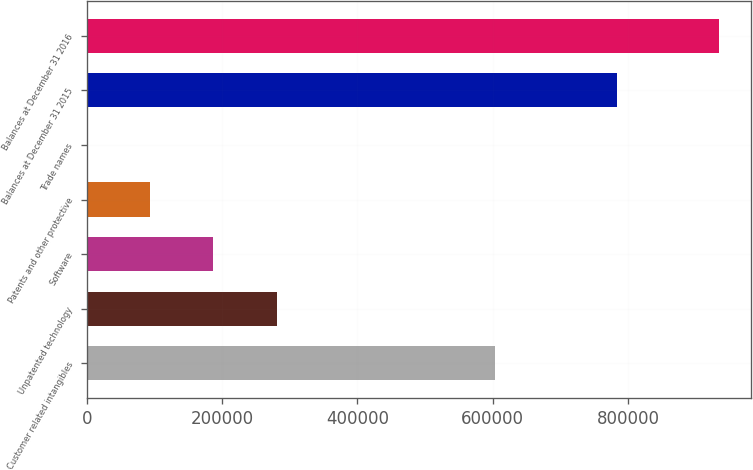Convert chart. <chart><loc_0><loc_0><loc_500><loc_500><bar_chart><fcel>Customer related intangibles<fcel>Unpatented technology<fcel>Software<fcel>Patents and other protective<fcel>Trade names<fcel>Balances at December 31 2015<fcel>Balances at December 31 2016<nl><fcel>602615<fcel>280488<fcel>187033<fcel>93577.5<fcel>122<fcel>783799<fcel>934677<nl></chart> 